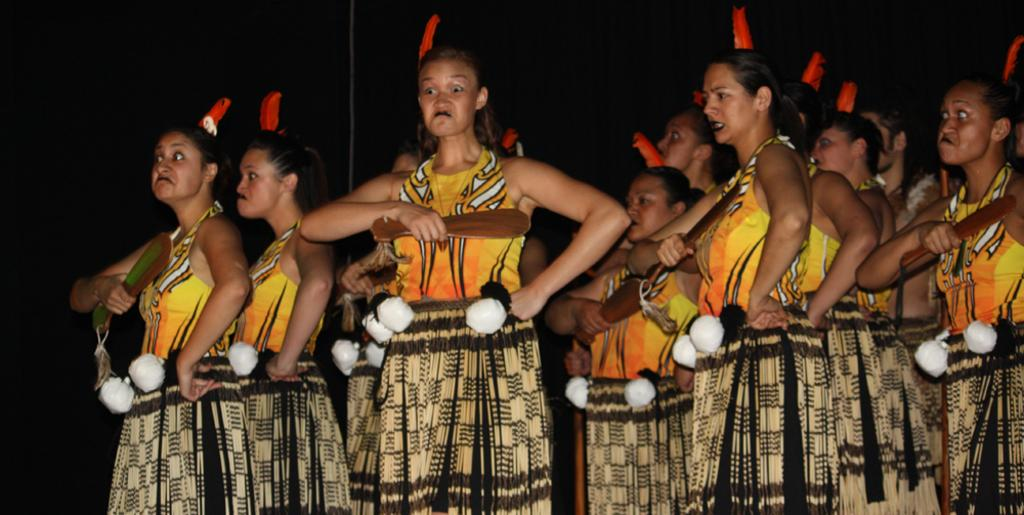What can be seen in the image? There is a group of women in the image. What are the women wearing? The women are wearing costumes. What are the women holding in their hands? The women are holding wooden sticks. What type of duck can be seen in the image? There is no duck present in the image; it features a group of women wearing costumes and holding wooden sticks. What sound does the pump make in the image? There is no pump present in the image, so it is not possible to determine the sound it would make. 